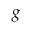<formula> <loc_0><loc_0><loc_500><loc_500>{ g }</formula> 